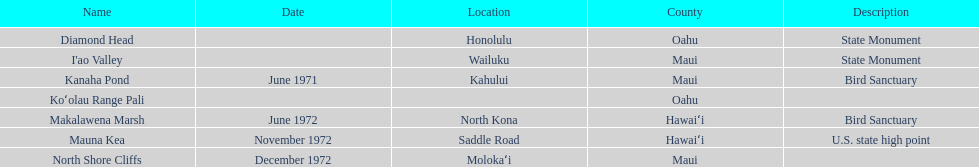Which is the sole name mentioned without a corresponding location? Koʻolau Range Pali. Can you parse all the data within this table? {'header': ['Name', 'Date', 'Location', 'County', 'Description'], 'rows': [['Diamond Head', '', 'Honolulu', 'Oahu', 'State Monument'], ["I'ao Valley", '', 'Wailuku', 'Maui', 'State Monument'], ['Kanaha Pond', 'June 1971', 'Kahului', 'Maui', 'Bird Sanctuary'], ['Koʻolau Range Pali', '', '', 'Oahu', ''], ['Makalawena Marsh', 'June 1972', 'North Kona', 'Hawaiʻi', 'Bird Sanctuary'], ['Mauna Kea', 'November 1972', 'Saddle Road', 'Hawaiʻi', 'U.S. state high point'], ['North Shore Cliffs', 'December 1972', 'Molokaʻi', 'Maui', '']]} 